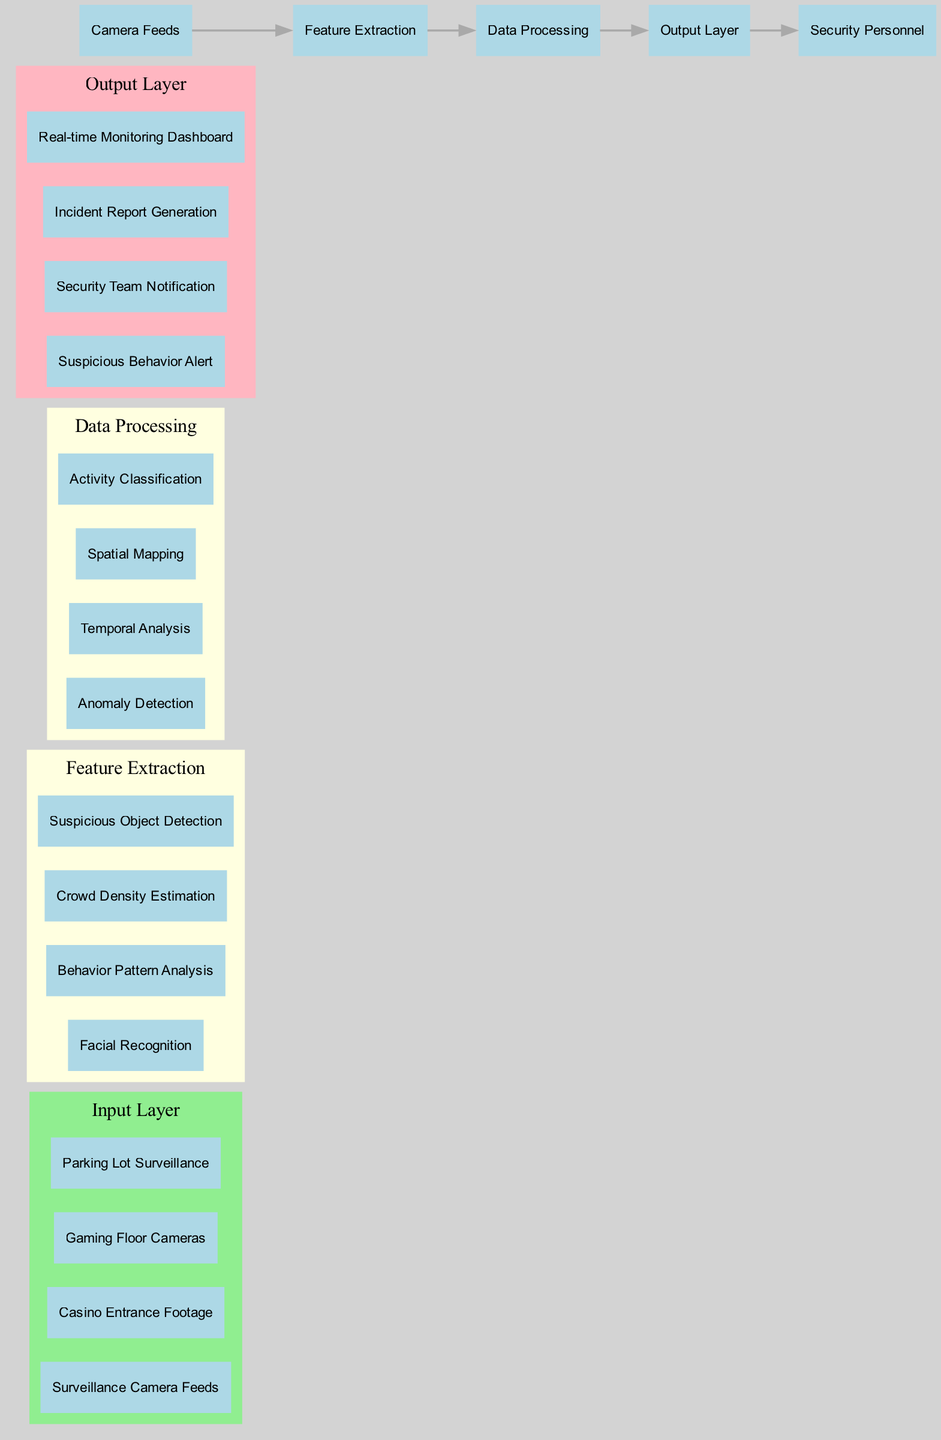What are the input sources for the neural network? The input sources for the neural network are detailed in the diagram under the input layer section. They include surveillance camera feeds, casino entrance footage, gaming floor cameras, and parking lot surveillance.
Answer: Surveillance Camera Feeds, Casino Entrance Footage, Gaming Floor Cameras, Parking Lot Surveillance How many nodes are in the feature extraction layer? The feature extraction hidden layer includes four nodes: facial recognition, behavior pattern analysis, crowd density estimation, and suspicious object detection. By counting these nodes, we verify the total is four.
Answer: 4 What type of layer processes anomaly detection and temporal analysis? The hidden layer designated for data processing handles both anomaly detection and temporal analysis as specified in the diagram. This layer is critical for processing data after feature extraction.
Answer: Data Processing Which node generates incident reports? In the output layer, incident report generation is explicitly mentioned as one of the nodes responsible for outputting critical information based on the analysis performed by earlier layers.
Answer: Incident Report Generation Which connections lead from the feature extraction to the output layer? The connections mentioned in the diagram indicate that the data processing layer connects to the output layer. Since data processing is the immediate next layer after feature extraction, it’s the only connection leading to the output layer.
Answer: Data Processing to Output Layer 